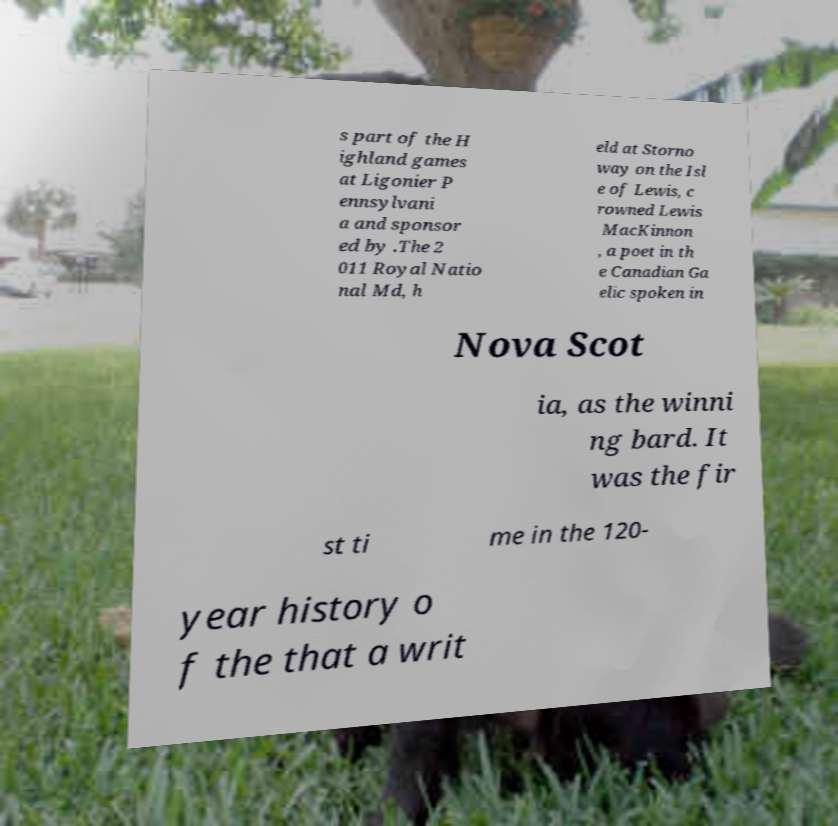Could you assist in decoding the text presented in this image and type it out clearly? s part of the H ighland games at Ligonier P ennsylvani a and sponsor ed by .The 2 011 Royal Natio nal Md, h eld at Storno way on the Isl e of Lewis, c rowned Lewis MacKinnon , a poet in th e Canadian Ga elic spoken in Nova Scot ia, as the winni ng bard. It was the fir st ti me in the 120- year history o f the that a writ 